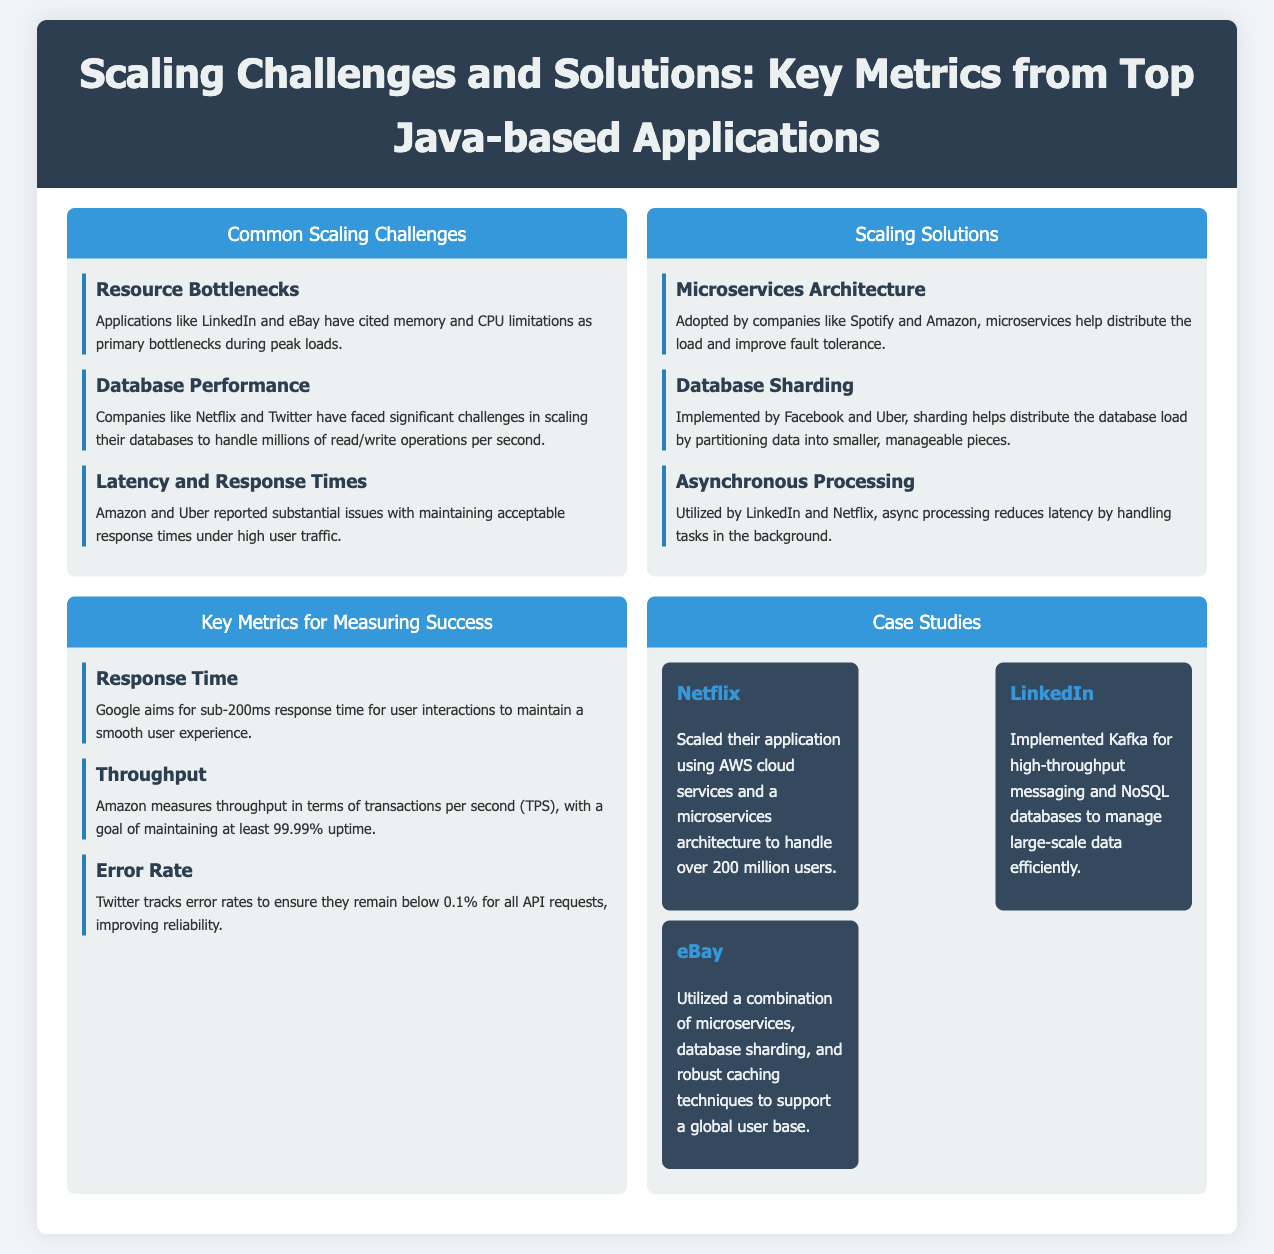What is a common scaling challenge mentioned? The document lists "Resource Bottlenecks," "Database Performance," and "Latency and Response Times" as common scaling challenges.
Answer: Resource Bottlenecks Which company faced database challenges? Netflix and Twitter are mentioned as companies that have faced significant database performance challenges.
Answer: Netflix, Twitter What is one scaling solution adopted by Spotify? The document states that Spotify adopted microservices architecture to help distribute the load.
Answer: Microservices Architecture What response time does Google aim for? According to the document, Google aims for a sub-200ms response time for user interactions.
Answer: Sub-200ms What is Twitter's maximum allowed error rate? The document specifies that Twitter tracks error rates to ensure they remain below 0.1% for all API requests.
Answer: 0.1% What technology did LinkedIn implement for messaging? The document mentions that LinkedIn implemented Kafka for high-throughput messaging.
Answer: Kafka What is the goal for Amazon's transactions per second (TPS)? Amazon aims for at least 99.99% uptime for their transactions per second (TPS).
Answer: 99.99% Which company utilizes AWS cloud services? The document states that Netflix scaled their application using AWS cloud services.
Answer: Netflix 